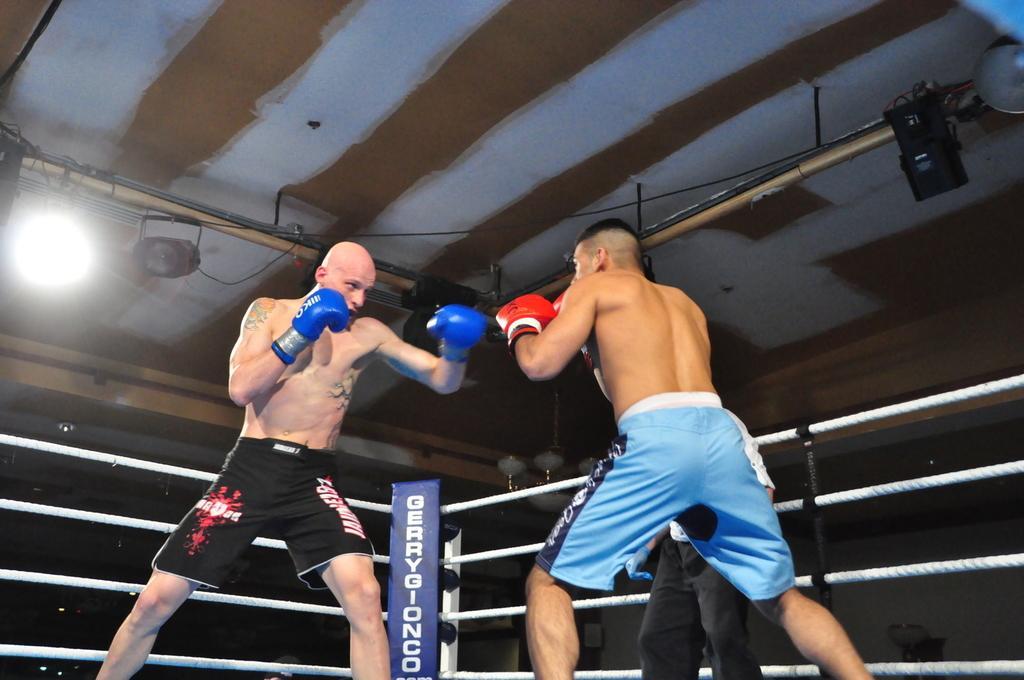Can you describe this image briefly? In this image there are two boxers fighting with each other in a boxing ring, beside them there is a referee. At the top of the image there are focus lamps on the metal rods and there are cables. 